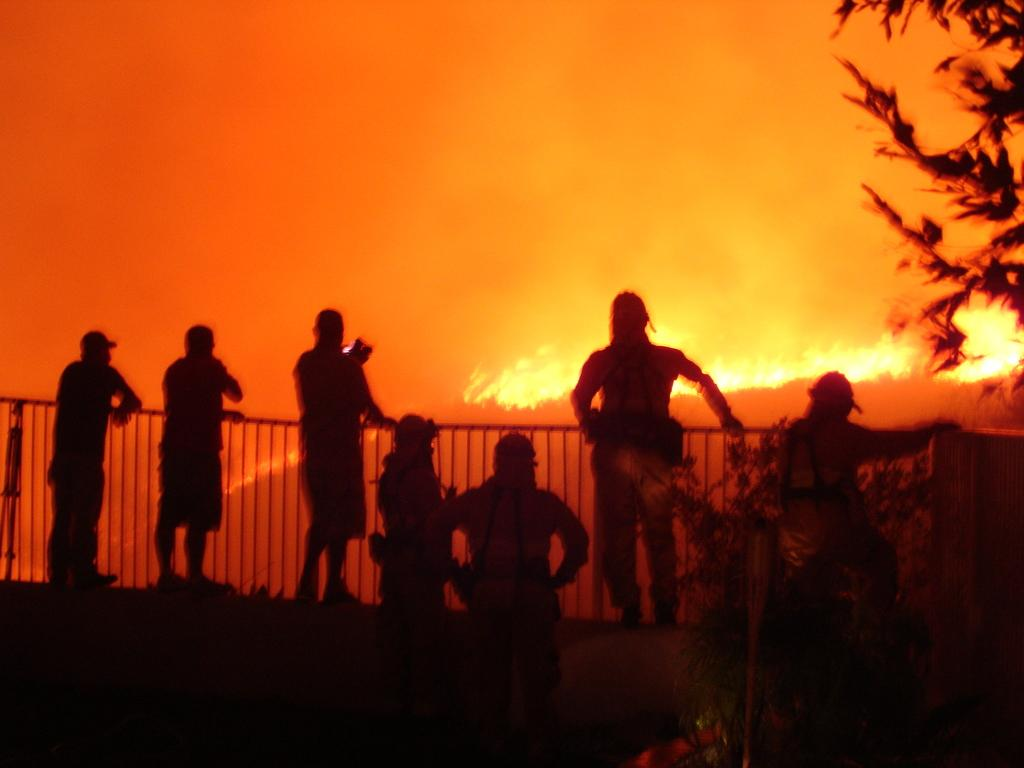What are the people in the image doing? The people in the image are standing near the railing. What can be seen on the right side of the image? There is a plant and a tree on the right side of the image. What is visible in the background of the image? There is smoke and fire visible in the background of the image. How many giants are playing cards in the image? There are no giants or playing cards present in the image. 